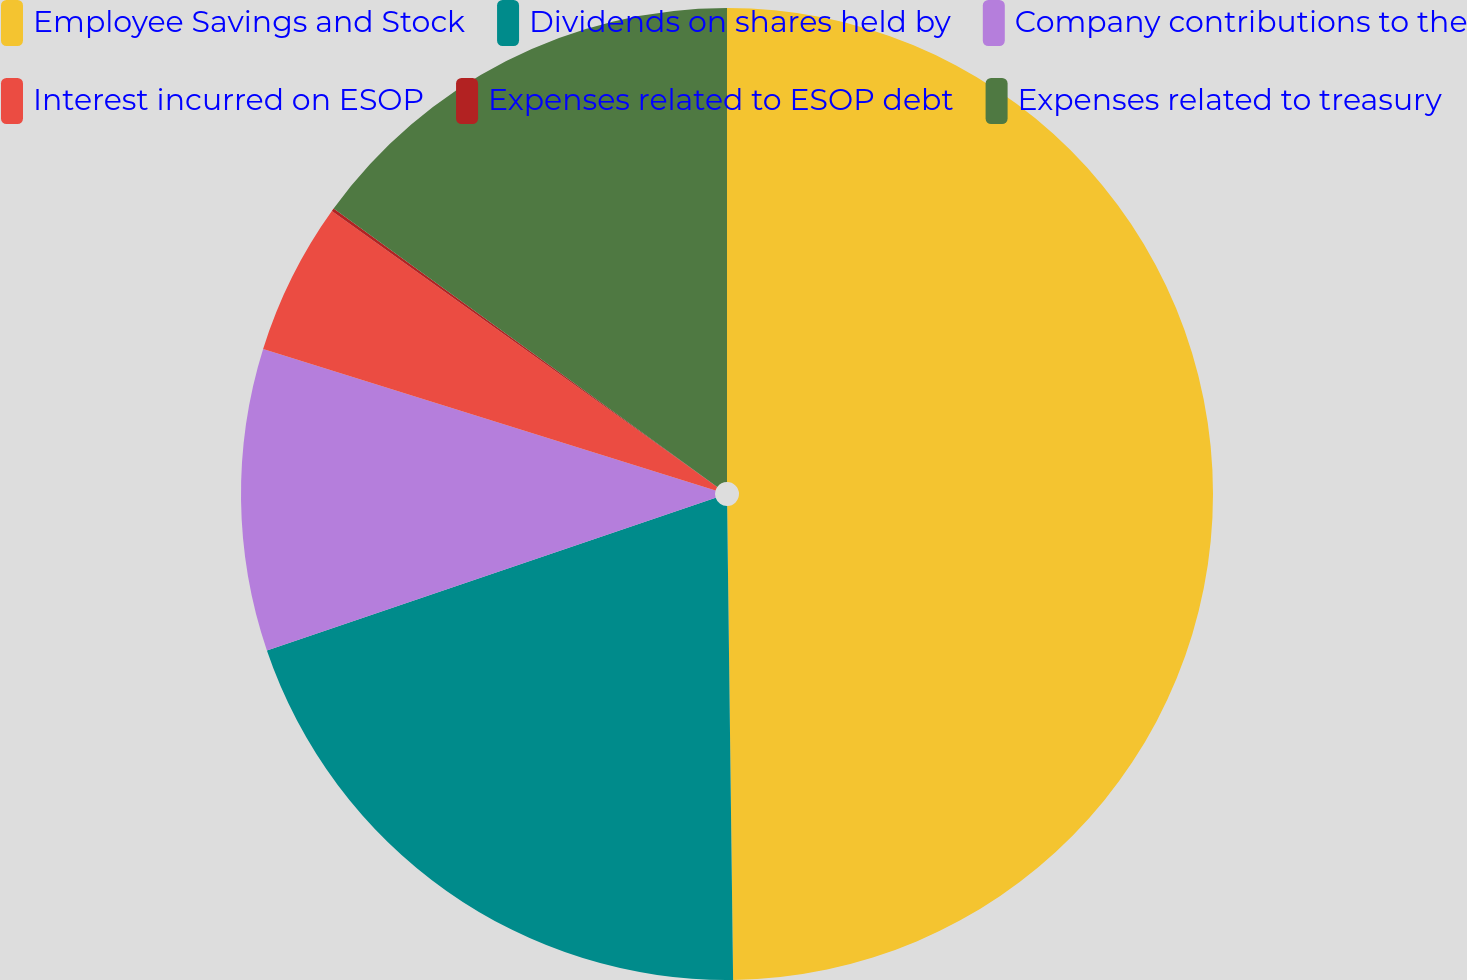Convert chart. <chart><loc_0><loc_0><loc_500><loc_500><pie_chart><fcel>Employee Savings and Stock<fcel>Dividends on shares held by<fcel>Company contributions to the<fcel>Interest incurred on ESOP<fcel>Expenses related to ESOP debt<fcel>Expenses related to treasury<nl><fcel>49.8%<fcel>19.98%<fcel>10.04%<fcel>5.07%<fcel>0.1%<fcel>15.01%<nl></chart> 